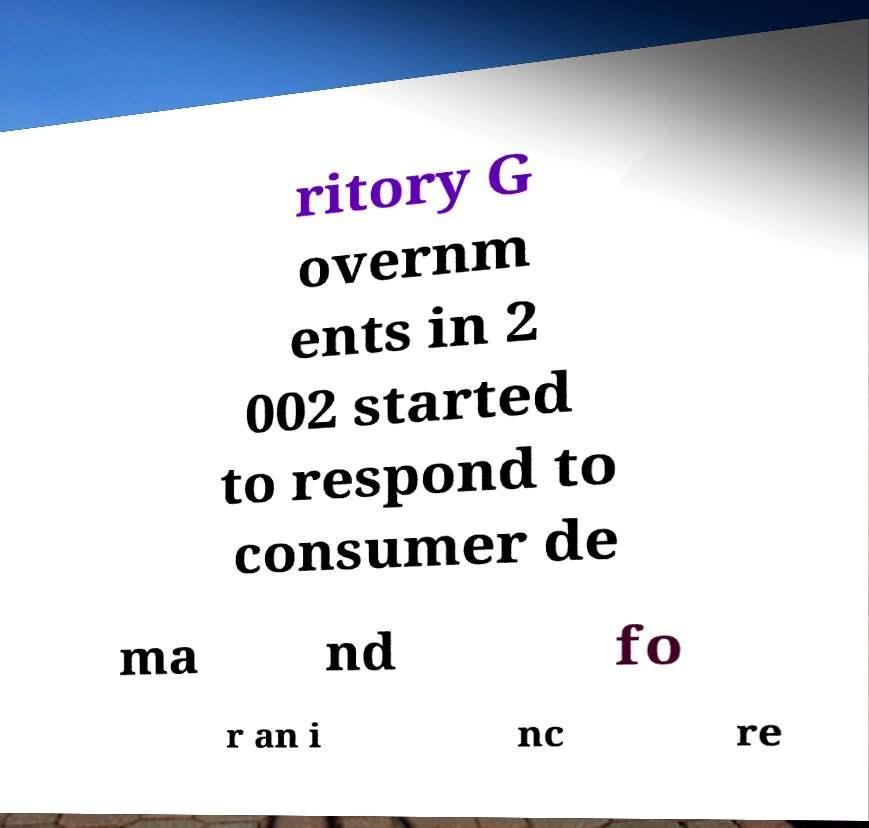Please read and relay the text visible in this image. What does it say? ritory G overnm ents in 2 002 started to respond to consumer de ma nd fo r an i nc re 